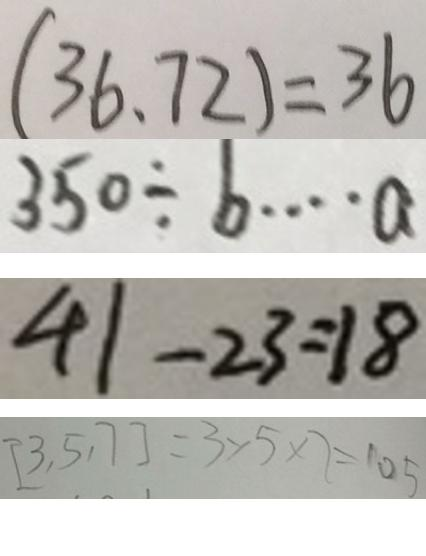<formula> <loc_0><loc_0><loc_500><loc_500>( 3 6 、 7 2 ) = 3 6 
 3 5 0 \div b \cdots a 
 4 1 - 2 3 = 1 8 
 [ 3 , 5 , 7 ] = 3 \times 5 \times 7 = 1 0 5</formula> 